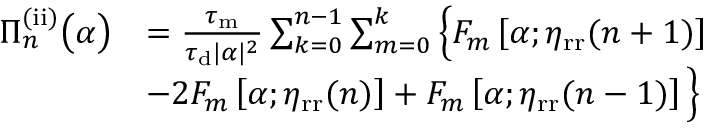<formula> <loc_0><loc_0><loc_500><loc_500>\begin{array} { r l } { \Pi _ { n } ^ { ( i i ) } \left ( \alpha \right ) } & { = \frac { \tau _ { m } } { \tau _ { d } | \alpha | ^ { 2 } } \sum _ { k = 0 } ^ { n - 1 } \sum _ { m = 0 } ^ { k } \left \{ F _ { m } \left [ \alpha ; \eta _ { r r } ( n + 1 ) \right ] } \\ & { - 2 F _ { m } \left [ \alpha ; \eta _ { r r } ( n ) \right ] + F _ { m } \left [ \alpha ; \eta _ { r r } ( n - 1 ) \right ] \right \} } \end{array}</formula> 